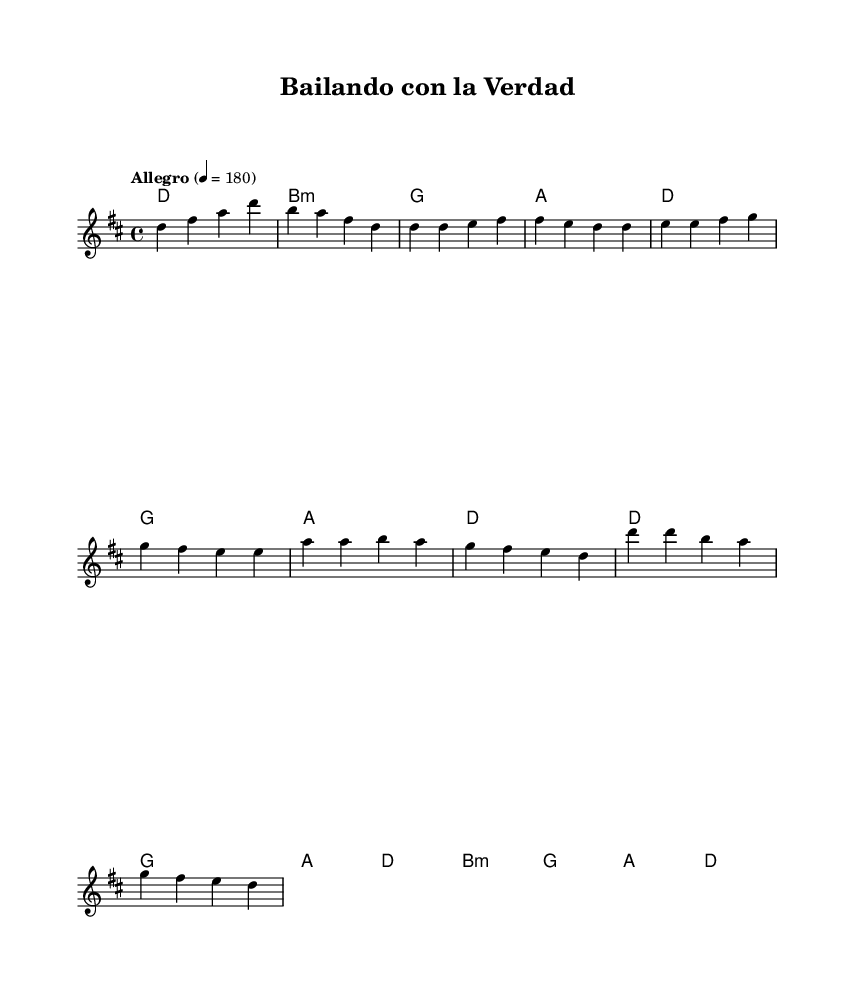What is the key signature of this music? The key signature is D major, which has two sharps (F# and C#). The notation in the score confirms it is written in D major.
Answer: D major What is the time signature of this music? The time signature is 4/4, indicated at the beginning of the score after the key signature. This means there are four beats per measure and a quarter note gets one beat.
Answer: 4/4 What is the tempo of this music? The tempo is marked as "Allegro," which typically indicates a fast tempo. The specific marking notes a speed of 180 beats per minute, which is stated directly in the score.
Answer: Allegro How many measures are in the chorus? The chorus consists of 8 measures. By analyzing the melody section for the chorus, you can count the individual measures which total 8.
Answer: 8 What chord follows the introduction? The chord following the introduction is G major. It is clearly stated in the harmony section after the introduction chord of D major.
Answer: G What is the last note of the melody? The last note of the melody is D. By examining the melody line, the final note appears in the last measure of the score.
Answer: D What type of song structure is used in this piece? The piece uses a verse-chorus structure. This can be seen by the separate sections labeled as "Verse" and "Chorus" in the melody outline of the score.
Answer: Verse-Chorus 